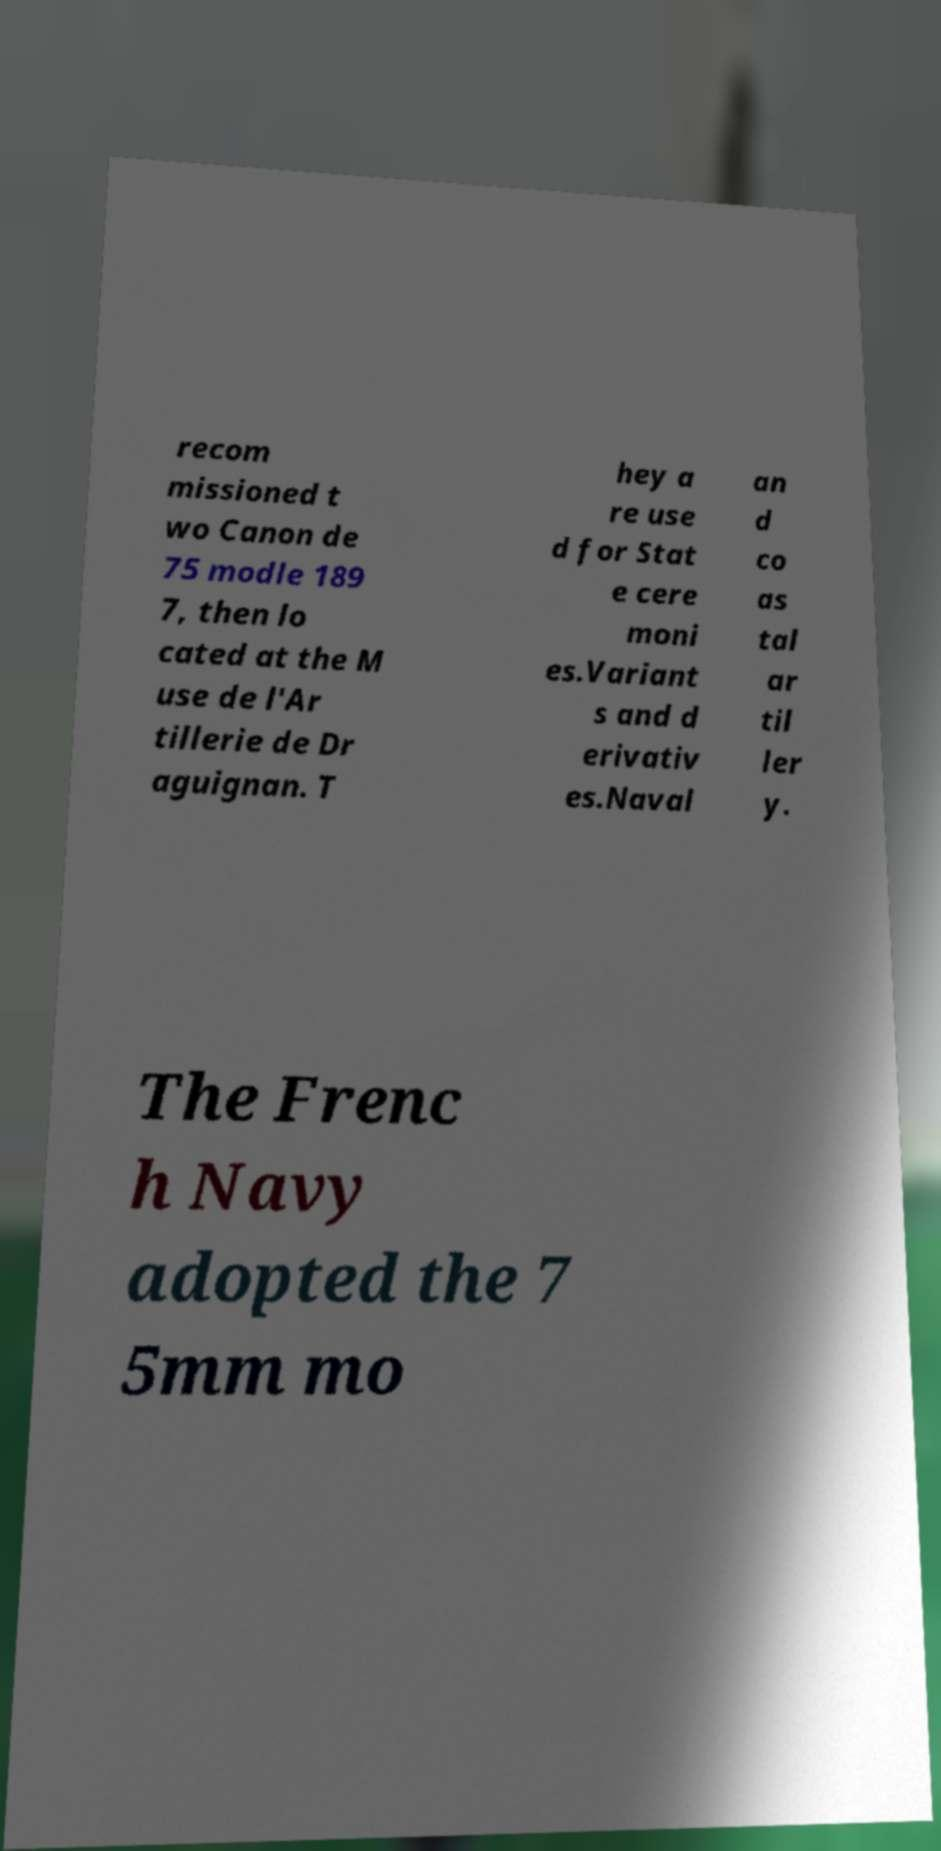I need the written content from this picture converted into text. Can you do that? recom missioned t wo Canon de 75 modle 189 7, then lo cated at the M use de l'Ar tillerie de Dr aguignan. T hey a re use d for Stat e cere moni es.Variant s and d erivativ es.Naval an d co as tal ar til ler y. The Frenc h Navy adopted the 7 5mm mo 